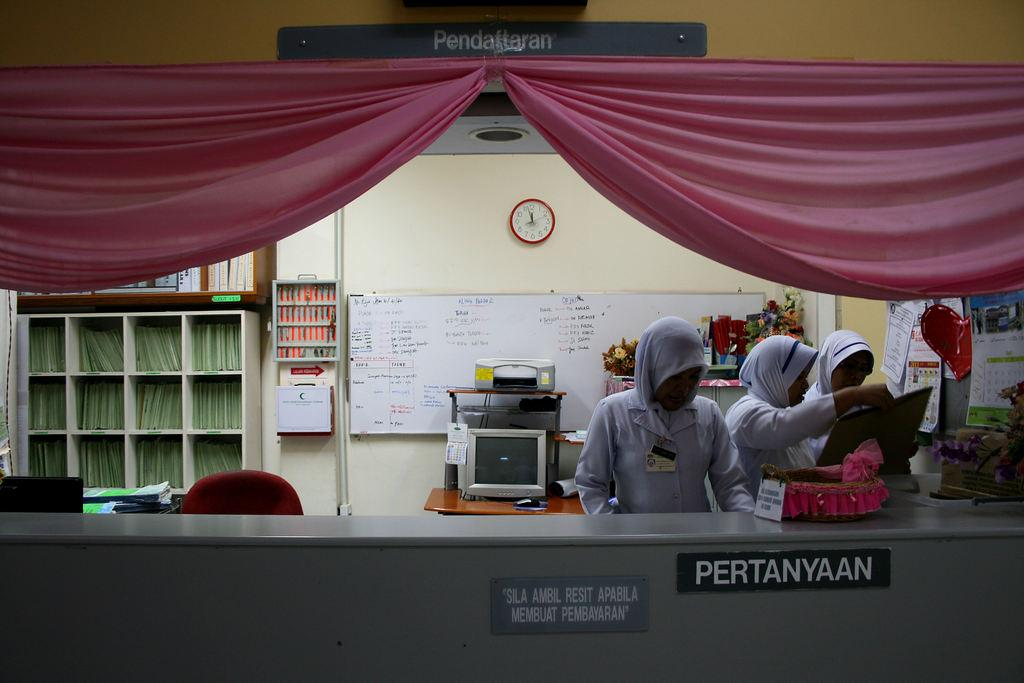How many people are in the image? There are people in the image, but the exact number is not specified. What are the people in the image doing? The people in the image are standing. What type of twig can be seen shaking in the image? There is no twig present in the image, and therefore no shaking can be observed. 